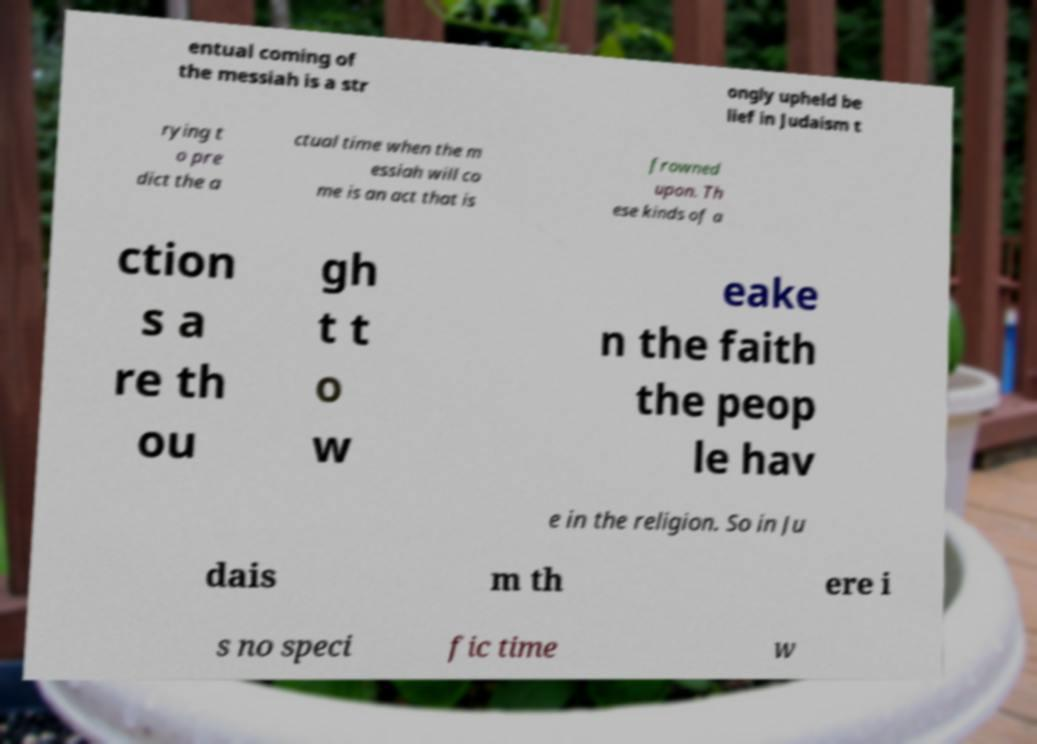Could you assist in decoding the text presented in this image and type it out clearly? entual coming of the messiah is a str ongly upheld be lief in Judaism t rying t o pre dict the a ctual time when the m essiah will co me is an act that is frowned upon. Th ese kinds of a ction s a re th ou gh t t o w eake n the faith the peop le hav e in the religion. So in Ju dais m th ere i s no speci fic time w 